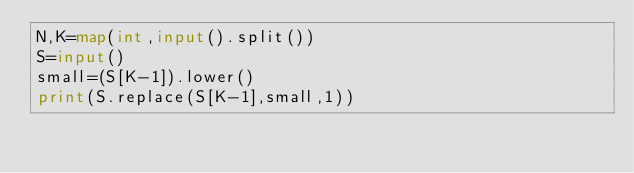Convert code to text. <code><loc_0><loc_0><loc_500><loc_500><_Python_>N,K=map(int,input().split())
S=input()
small=(S[K-1]).lower()
print(S.replace(S[K-1],small,1))
</code> 